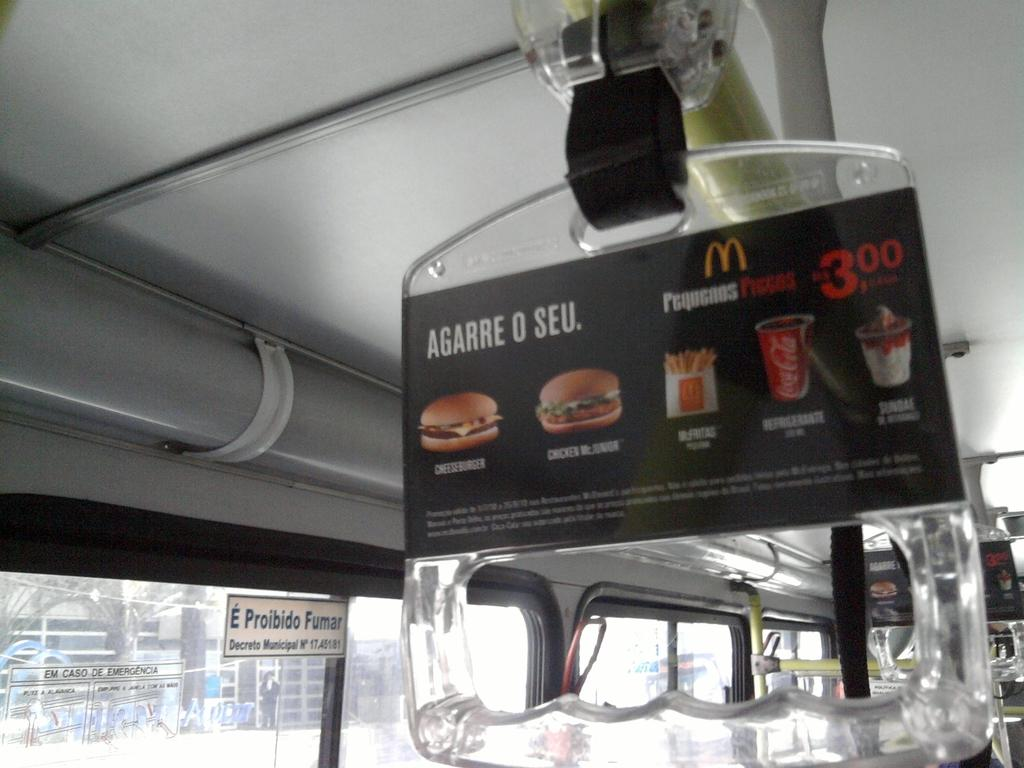What type of vehicle is shown in the image? The image is an inside view of a bus. What can be seen attached to the holder in the image? There is an advertisement in the holder in the image. Can you see a yak sitting next to the advertisement in the image? No, there is no yak present in the image. 